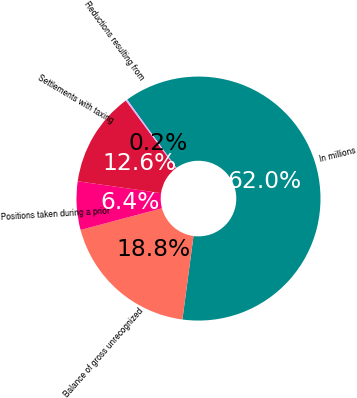<chart> <loc_0><loc_0><loc_500><loc_500><pie_chart><fcel>In millions<fcel>Balance of gross unrecognized<fcel>Positions taken during a prior<fcel>Settlements with taxing<fcel>Reductions resulting from<nl><fcel>62.04%<fcel>18.76%<fcel>6.4%<fcel>12.58%<fcel>0.22%<nl></chart> 